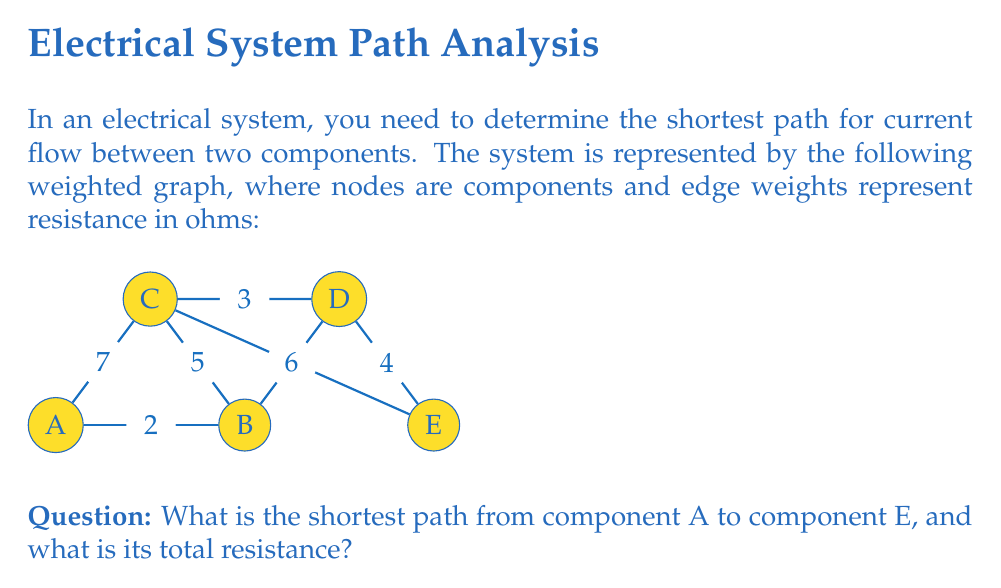Provide a solution to this math problem. To solve this problem, we'll use Dijkstra's algorithm, which is an efficient method for finding the shortest path in a weighted graph.

Step 1: Initialize distances
Set the distance to A as 0 and all other nodes as infinity.
$d(A) = 0$, $d(B) = d(C) = d(D) = d(E) = \infty$

Step 2: Visit node A
Update neighbors of A:
$d(B) = \min(\infty, 0 + 2) = 2$
$d(C) = \min(\infty, 0 + 7) = 7$

Step 3: Visit node B (smallest unvisited distance)
Update neighbors of B:
$d(C) = \min(7, 2 + 5) = 7$
$d(D) = \min(\infty, 2 + 6) = 8$

Step 4: Visit node C
Update neighbors of C:
$d(D) = \min(8, 7 + 3) = 8$
$d(E) = \min(\infty, 7 + 8) = 15$

Step 5: Visit node D
Update neighbors of D:
$d(E) = \min(15, 8 + 4) = 12$

Step 6: Visit node E
Algorithm terminates as we've reached the destination.

The shortest path is A → B → D → E with a total resistance of 12 ohms.
Answer: A → B → D → E, 12 ohms 